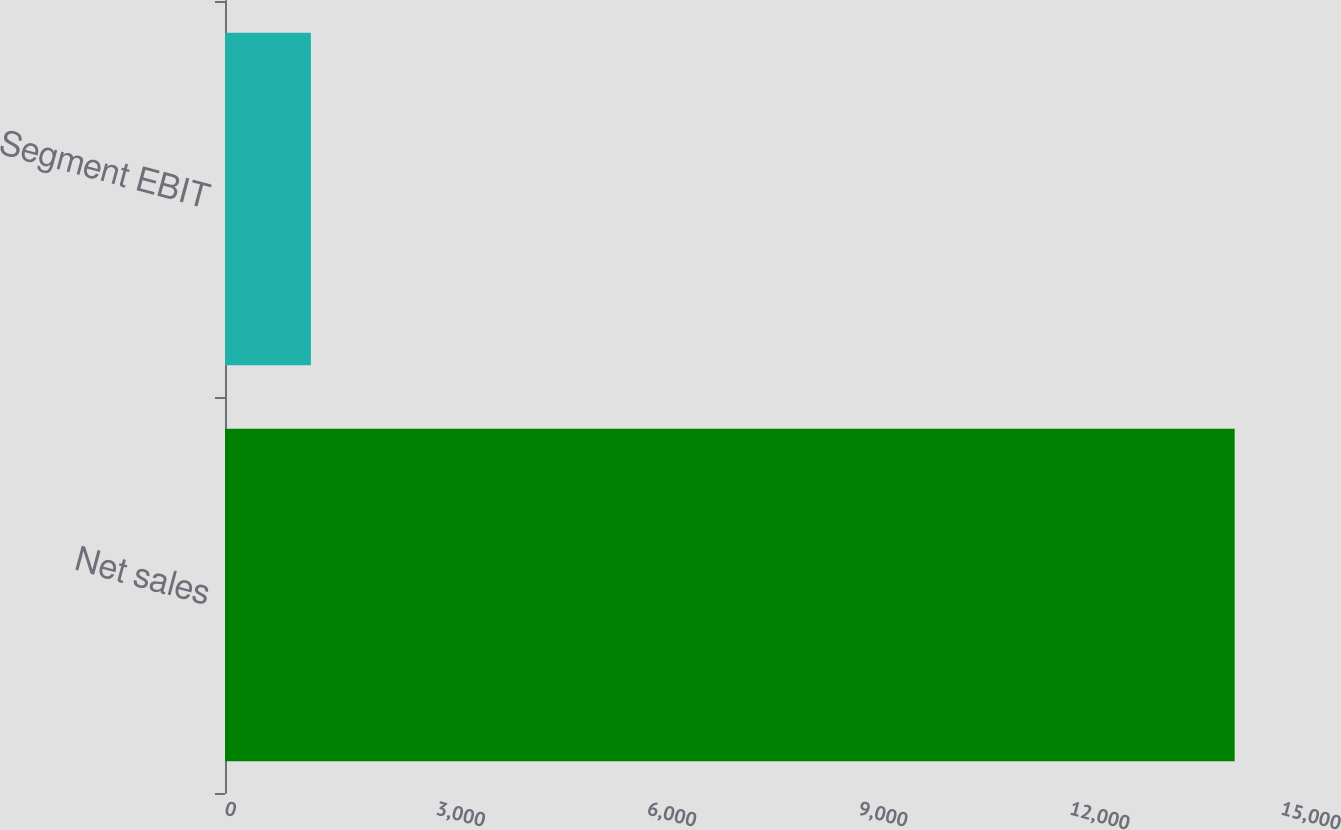Convert chart to OTSL. <chart><loc_0><loc_0><loc_500><loc_500><bar_chart><fcel>Net sales<fcel>Segment EBIT<nl><fcel>14342<fcel>1220<nl></chart> 